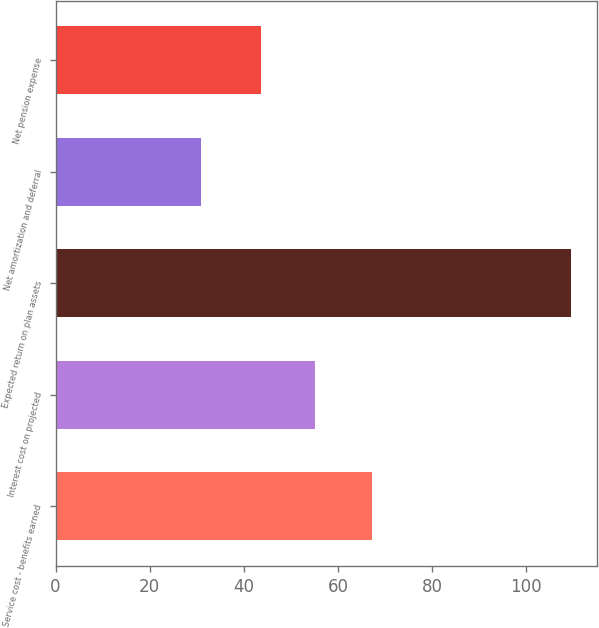Convert chart to OTSL. <chart><loc_0><loc_0><loc_500><loc_500><bar_chart><fcel>Service cost - benefits earned<fcel>Interest cost on projected<fcel>Expected return on plan assets<fcel>Net amortization and deferral<fcel>Net pension expense<nl><fcel>67.2<fcel>55.1<fcel>109.5<fcel>30.9<fcel>43.7<nl></chart> 